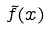<formula> <loc_0><loc_0><loc_500><loc_500>\tilde { f } ( x )</formula> 